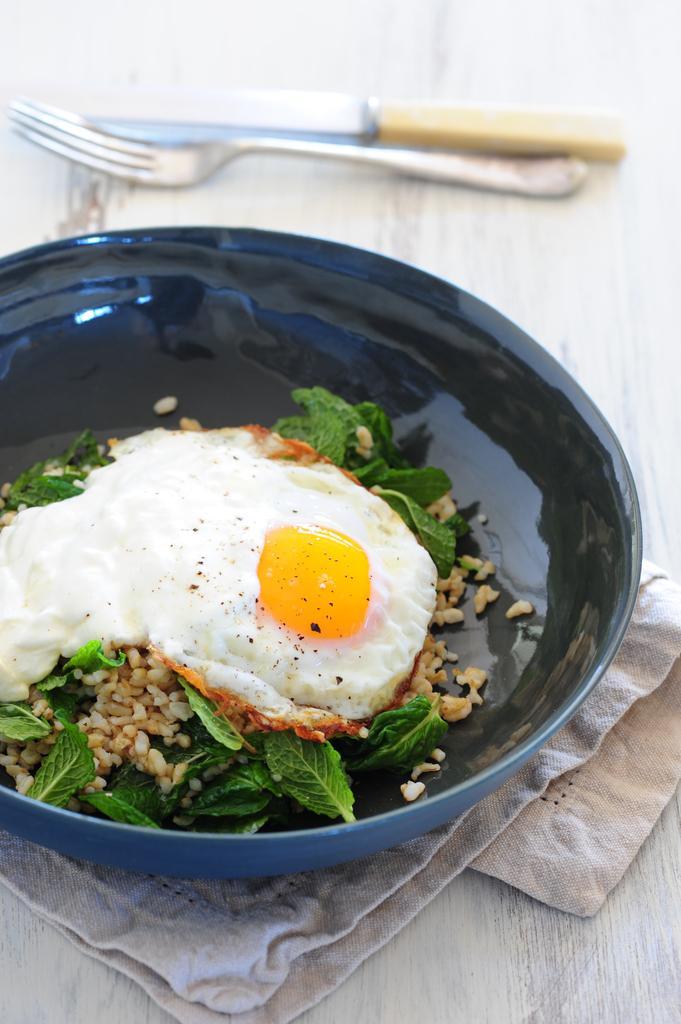Please provide a concise description of this image. In the image I can see a food in the black and blue color bowl. I can see a cloth,spoon,knife on the white surface. 